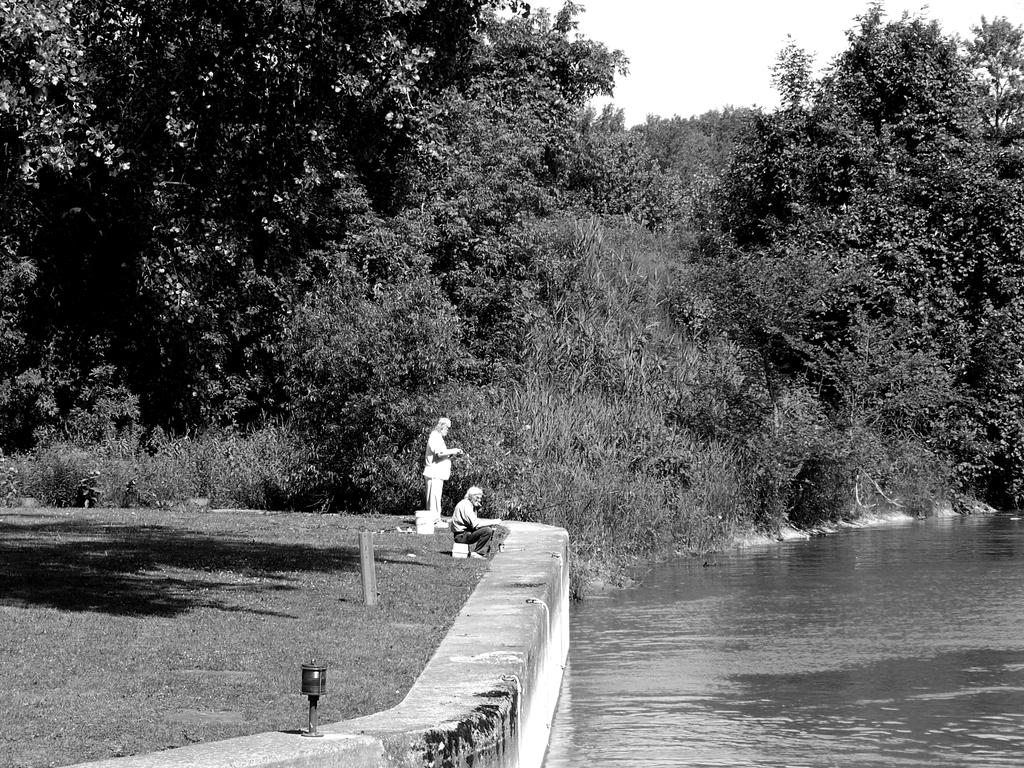How many people are in the image? There are two men in the image. What is the position of the men in the image? The men are on the ground. What natural element can be seen in the image? There is water visible in the image. What type of vegetation is present in the image? There are trees in the image. What is visible in the background of the image? The sky is visible in the background of the image. What type of ray can be seen swimming in the water in the image? There is no ray visible in the water in the image. What attempt is being made by the men in the image? The image does not provide any information about an attempt being made by the men. 